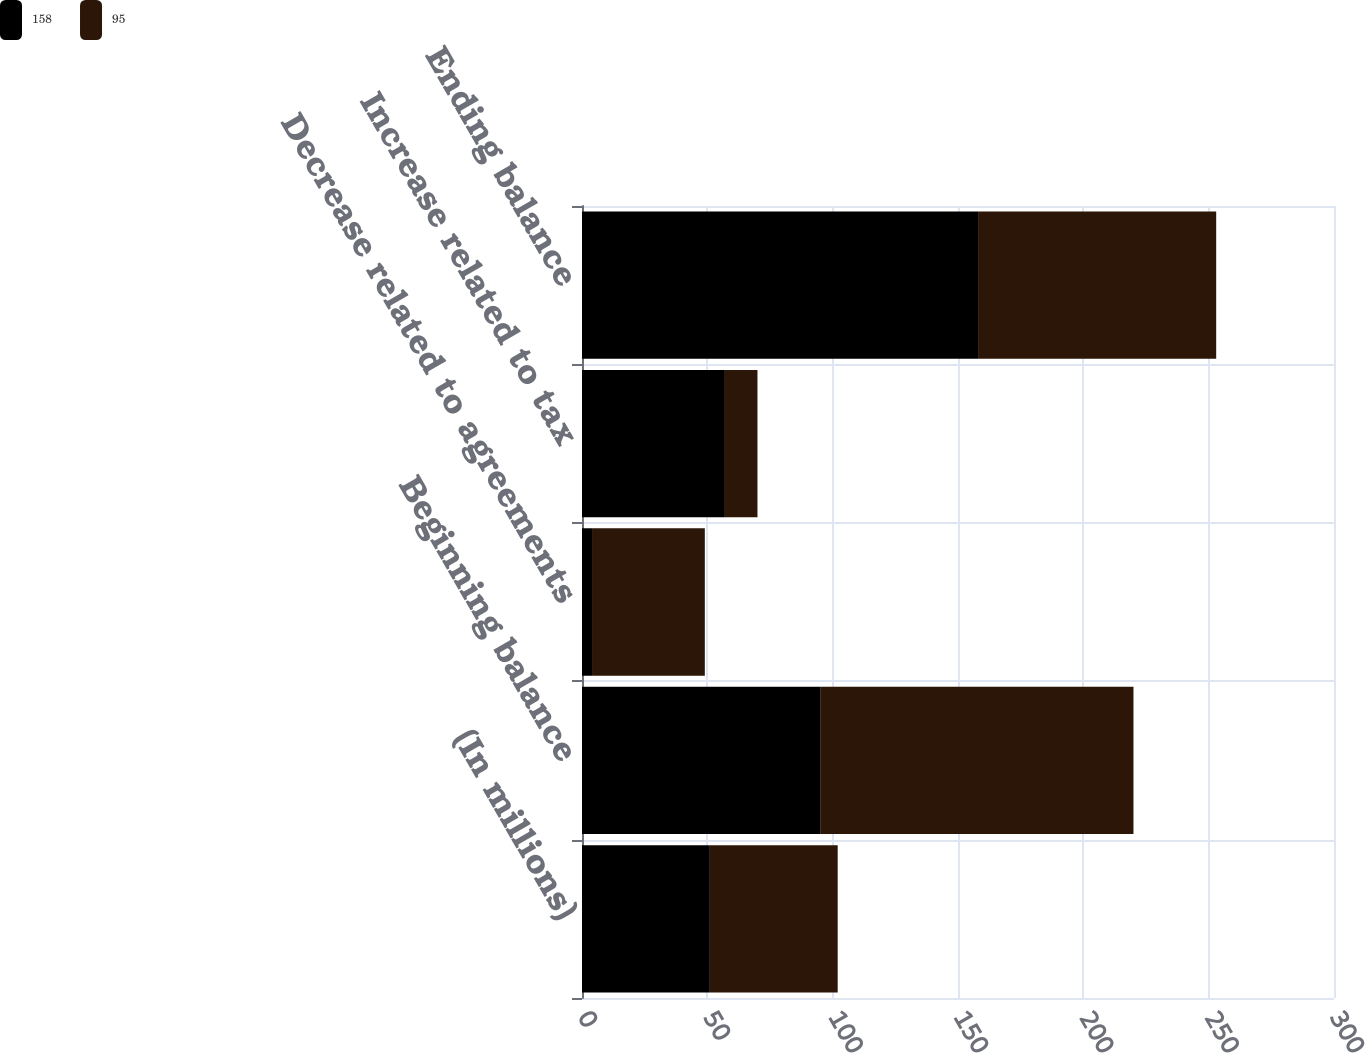Convert chart. <chart><loc_0><loc_0><loc_500><loc_500><stacked_bar_chart><ecel><fcel>(In millions)<fcel>Beginning balance<fcel>Decrease related to agreements<fcel>Increase related to tax<fcel>Ending balance<nl><fcel>158<fcel>51<fcel>95<fcel>4<fcel>57<fcel>158<nl><fcel>95<fcel>51<fcel>125<fcel>45<fcel>13<fcel>95<nl></chart> 